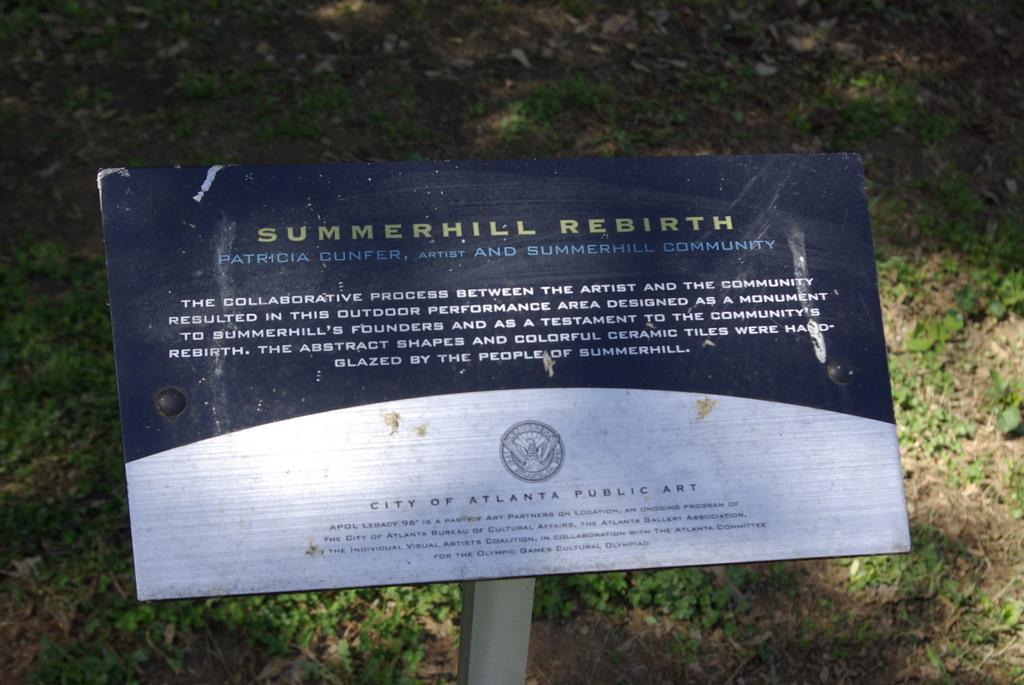Could you give a brief overview of what you see in this image? In this picture I can see a board with some text and I can see grass on the ground. 